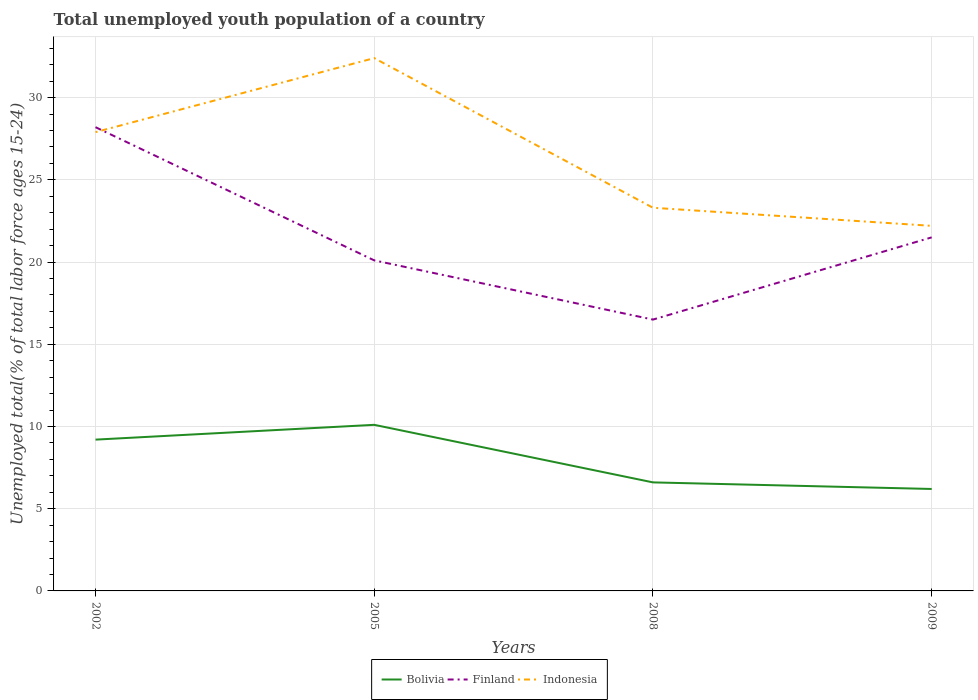Is the number of lines equal to the number of legend labels?
Give a very brief answer. Yes. Across all years, what is the maximum percentage of total unemployed youth population of a country in Indonesia?
Offer a terse response. 22.2. What is the total percentage of total unemployed youth population of a country in Bolivia in the graph?
Keep it short and to the point. 2.6. What is the difference between the highest and the second highest percentage of total unemployed youth population of a country in Finland?
Provide a short and direct response. 11.7. Is the percentage of total unemployed youth population of a country in Finland strictly greater than the percentage of total unemployed youth population of a country in Indonesia over the years?
Give a very brief answer. No. How many lines are there?
Your response must be concise. 3. Are the values on the major ticks of Y-axis written in scientific E-notation?
Offer a very short reply. No. Does the graph contain any zero values?
Ensure brevity in your answer.  No. Does the graph contain grids?
Give a very brief answer. Yes. Where does the legend appear in the graph?
Your answer should be very brief. Bottom center. How many legend labels are there?
Ensure brevity in your answer.  3. What is the title of the graph?
Offer a very short reply. Total unemployed youth population of a country. Does "Togo" appear as one of the legend labels in the graph?
Provide a succinct answer. No. What is the label or title of the X-axis?
Your answer should be very brief. Years. What is the label or title of the Y-axis?
Provide a short and direct response. Unemployed total(% of total labor force ages 15-24). What is the Unemployed total(% of total labor force ages 15-24) in Bolivia in 2002?
Your answer should be compact. 9.2. What is the Unemployed total(% of total labor force ages 15-24) in Finland in 2002?
Keep it short and to the point. 28.2. What is the Unemployed total(% of total labor force ages 15-24) of Indonesia in 2002?
Your answer should be very brief. 27.9. What is the Unemployed total(% of total labor force ages 15-24) in Bolivia in 2005?
Your answer should be compact. 10.1. What is the Unemployed total(% of total labor force ages 15-24) in Finland in 2005?
Offer a very short reply. 20.1. What is the Unemployed total(% of total labor force ages 15-24) of Indonesia in 2005?
Your response must be concise. 32.4. What is the Unemployed total(% of total labor force ages 15-24) in Bolivia in 2008?
Your answer should be very brief. 6.6. What is the Unemployed total(% of total labor force ages 15-24) in Finland in 2008?
Give a very brief answer. 16.5. What is the Unemployed total(% of total labor force ages 15-24) in Indonesia in 2008?
Provide a succinct answer. 23.3. What is the Unemployed total(% of total labor force ages 15-24) of Bolivia in 2009?
Provide a succinct answer. 6.2. What is the Unemployed total(% of total labor force ages 15-24) of Indonesia in 2009?
Your answer should be compact. 22.2. Across all years, what is the maximum Unemployed total(% of total labor force ages 15-24) of Bolivia?
Your answer should be compact. 10.1. Across all years, what is the maximum Unemployed total(% of total labor force ages 15-24) in Finland?
Your response must be concise. 28.2. Across all years, what is the maximum Unemployed total(% of total labor force ages 15-24) in Indonesia?
Ensure brevity in your answer.  32.4. Across all years, what is the minimum Unemployed total(% of total labor force ages 15-24) of Bolivia?
Give a very brief answer. 6.2. Across all years, what is the minimum Unemployed total(% of total labor force ages 15-24) in Finland?
Provide a succinct answer. 16.5. Across all years, what is the minimum Unemployed total(% of total labor force ages 15-24) of Indonesia?
Provide a short and direct response. 22.2. What is the total Unemployed total(% of total labor force ages 15-24) in Bolivia in the graph?
Ensure brevity in your answer.  32.1. What is the total Unemployed total(% of total labor force ages 15-24) of Finland in the graph?
Provide a short and direct response. 86.3. What is the total Unemployed total(% of total labor force ages 15-24) of Indonesia in the graph?
Your answer should be very brief. 105.8. What is the difference between the Unemployed total(% of total labor force ages 15-24) of Finland in 2002 and that in 2005?
Ensure brevity in your answer.  8.1. What is the difference between the Unemployed total(% of total labor force ages 15-24) in Indonesia in 2002 and that in 2005?
Keep it short and to the point. -4.5. What is the difference between the Unemployed total(% of total labor force ages 15-24) of Bolivia in 2002 and that in 2008?
Your answer should be compact. 2.6. What is the difference between the Unemployed total(% of total labor force ages 15-24) in Finland in 2002 and that in 2008?
Offer a very short reply. 11.7. What is the difference between the Unemployed total(% of total labor force ages 15-24) in Finland in 2002 and that in 2009?
Your response must be concise. 6.7. What is the difference between the Unemployed total(% of total labor force ages 15-24) in Indonesia in 2002 and that in 2009?
Your response must be concise. 5.7. What is the difference between the Unemployed total(% of total labor force ages 15-24) in Bolivia in 2005 and that in 2009?
Make the answer very short. 3.9. What is the difference between the Unemployed total(% of total labor force ages 15-24) of Bolivia in 2008 and that in 2009?
Provide a succinct answer. 0.4. What is the difference between the Unemployed total(% of total labor force ages 15-24) of Bolivia in 2002 and the Unemployed total(% of total labor force ages 15-24) of Indonesia in 2005?
Your answer should be very brief. -23.2. What is the difference between the Unemployed total(% of total labor force ages 15-24) of Bolivia in 2002 and the Unemployed total(% of total labor force ages 15-24) of Indonesia in 2008?
Make the answer very short. -14.1. What is the difference between the Unemployed total(% of total labor force ages 15-24) in Finland in 2002 and the Unemployed total(% of total labor force ages 15-24) in Indonesia in 2008?
Offer a very short reply. 4.9. What is the difference between the Unemployed total(% of total labor force ages 15-24) in Bolivia in 2002 and the Unemployed total(% of total labor force ages 15-24) in Finland in 2009?
Give a very brief answer. -12.3. What is the difference between the Unemployed total(% of total labor force ages 15-24) of Bolivia in 2002 and the Unemployed total(% of total labor force ages 15-24) of Indonesia in 2009?
Offer a very short reply. -13. What is the difference between the Unemployed total(% of total labor force ages 15-24) of Finland in 2002 and the Unemployed total(% of total labor force ages 15-24) of Indonesia in 2009?
Keep it short and to the point. 6. What is the difference between the Unemployed total(% of total labor force ages 15-24) in Bolivia in 2005 and the Unemployed total(% of total labor force ages 15-24) in Finland in 2008?
Provide a short and direct response. -6.4. What is the difference between the Unemployed total(% of total labor force ages 15-24) in Finland in 2005 and the Unemployed total(% of total labor force ages 15-24) in Indonesia in 2008?
Provide a succinct answer. -3.2. What is the difference between the Unemployed total(% of total labor force ages 15-24) of Bolivia in 2005 and the Unemployed total(% of total labor force ages 15-24) of Finland in 2009?
Your response must be concise. -11.4. What is the difference between the Unemployed total(% of total labor force ages 15-24) in Bolivia in 2008 and the Unemployed total(% of total labor force ages 15-24) in Finland in 2009?
Give a very brief answer. -14.9. What is the difference between the Unemployed total(% of total labor force ages 15-24) in Bolivia in 2008 and the Unemployed total(% of total labor force ages 15-24) in Indonesia in 2009?
Provide a short and direct response. -15.6. What is the difference between the Unemployed total(% of total labor force ages 15-24) in Finland in 2008 and the Unemployed total(% of total labor force ages 15-24) in Indonesia in 2009?
Offer a very short reply. -5.7. What is the average Unemployed total(% of total labor force ages 15-24) in Bolivia per year?
Offer a terse response. 8.03. What is the average Unemployed total(% of total labor force ages 15-24) in Finland per year?
Offer a very short reply. 21.57. What is the average Unemployed total(% of total labor force ages 15-24) of Indonesia per year?
Provide a short and direct response. 26.45. In the year 2002, what is the difference between the Unemployed total(% of total labor force ages 15-24) of Bolivia and Unemployed total(% of total labor force ages 15-24) of Indonesia?
Offer a terse response. -18.7. In the year 2002, what is the difference between the Unemployed total(% of total labor force ages 15-24) in Finland and Unemployed total(% of total labor force ages 15-24) in Indonesia?
Ensure brevity in your answer.  0.3. In the year 2005, what is the difference between the Unemployed total(% of total labor force ages 15-24) in Bolivia and Unemployed total(% of total labor force ages 15-24) in Finland?
Your answer should be compact. -10. In the year 2005, what is the difference between the Unemployed total(% of total labor force ages 15-24) in Bolivia and Unemployed total(% of total labor force ages 15-24) in Indonesia?
Give a very brief answer. -22.3. In the year 2008, what is the difference between the Unemployed total(% of total labor force ages 15-24) of Bolivia and Unemployed total(% of total labor force ages 15-24) of Finland?
Make the answer very short. -9.9. In the year 2008, what is the difference between the Unemployed total(% of total labor force ages 15-24) of Bolivia and Unemployed total(% of total labor force ages 15-24) of Indonesia?
Provide a succinct answer. -16.7. In the year 2008, what is the difference between the Unemployed total(% of total labor force ages 15-24) of Finland and Unemployed total(% of total labor force ages 15-24) of Indonesia?
Offer a very short reply. -6.8. In the year 2009, what is the difference between the Unemployed total(% of total labor force ages 15-24) of Bolivia and Unemployed total(% of total labor force ages 15-24) of Finland?
Make the answer very short. -15.3. In the year 2009, what is the difference between the Unemployed total(% of total labor force ages 15-24) of Bolivia and Unemployed total(% of total labor force ages 15-24) of Indonesia?
Provide a succinct answer. -16. What is the ratio of the Unemployed total(% of total labor force ages 15-24) in Bolivia in 2002 to that in 2005?
Offer a very short reply. 0.91. What is the ratio of the Unemployed total(% of total labor force ages 15-24) in Finland in 2002 to that in 2005?
Ensure brevity in your answer.  1.4. What is the ratio of the Unemployed total(% of total labor force ages 15-24) of Indonesia in 2002 to that in 2005?
Your answer should be very brief. 0.86. What is the ratio of the Unemployed total(% of total labor force ages 15-24) in Bolivia in 2002 to that in 2008?
Provide a short and direct response. 1.39. What is the ratio of the Unemployed total(% of total labor force ages 15-24) in Finland in 2002 to that in 2008?
Provide a short and direct response. 1.71. What is the ratio of the Unemployed total(% of total labor force ages 15-24) in Indonesia in 2002 to that in 2008?
Offer a terse response. 1.2. What is the ratio of the Unemployed total(% of total labor force ages 15-24) in Bolivia in 2002 to that in 2009?
Provide a succinct answer. 1.48. What is the ratio of the Unemployed total(% of total labor force ages 15-24) in Finland in 2002 to that in 2009?
Ensure brevity in your answer.  1.31. What is the ratio of the Unemployed total(% of total labor force ages 15-24) in Indonesia in 2002 to that in 2009?
Provide a succinct answer. 1.26. What is the ratio of the Unemployed total(% of total labor force ages 15-24) in Bolivia in 2005 to that in 2008?
Keep it short and to the point. 1.53. What is the ratio of the Unemployed total(% of total labor force ages 15-24) of Finland in 2005 to that in 2008?
Your response must be concise. 1.22. What is the ratio of the Unemployed total(% of total labor force ages 15-24) of Indonesia in 2005 to that in 2008?
Keep it short and to the point. 1.39. What is the ratio of the Unemployed total(% of total labor force ages 15-24) of Bolivia in 2005 to that in 2009?
Your response must be concise. 1.63. What is the ratio of the Unemployed total(% of total labor force ages 15-24) of Finland in 2005 to that in 2009?
Your response must be concise. 0.93. What is the ratio of the Unemployed total(% of total labor force ages 15-24) of Indonesia in 2005 to that in 2009?
Your response must be concise. 1.46. What is the ratio of the Unemployed total(% of total labor force ages 15-24) of Bolivia in 2008 to that in 2009?
Offer a terse response. 1.06. What is the ratio of the Unemployed total(% of total labor force ages 15-24) in Finland in 2008 to that in 2009?
Give a very brief answer. 0.77. What is the ratio of the Unemployed total(% of total labor force ages 15-24) of Indonesia in 2008 to that in 2009?
Keep it short and to the point. 1.05. What is the difference between the highest and the second highest Unemployed total(% of total labor force ages 15-24) in Bolivia?
Your response must be concise. 0.9. What is the difference between the highest and the second highest Unemployed total(% of total labor force ages 15-24) in Finland?
Ensure brevity in your answer.  6.7. What is the difference between the highest and the second highest Unemployed total(% of total labor force ages 15-24) in Indonesia?
Offer a terse response. 4.5. What is the difference between the highest and the lowest Unemployed total(% of total labor force ages 15-24) of Bolivia?
Your answer should be compact. 3.9. What is the difference between the highest and the lowest Unemployed total(% of total labor force ages 15-24) in Indonesia?
Your answer should be very brief. 10.2. 